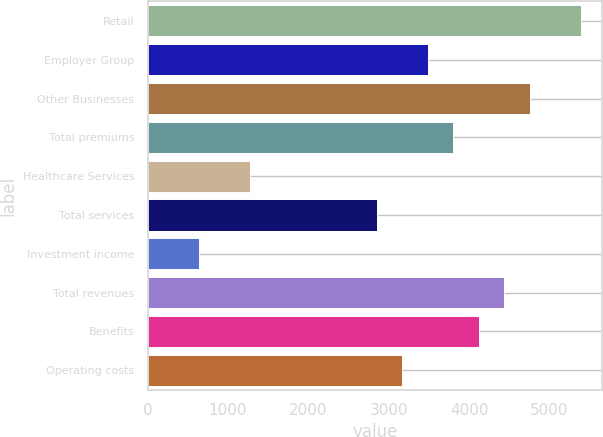Convert chart to OTSL. <chart><loc_0><loc_0><loc_500><loc_500><bar_chart><fcel>Retail<fcel>Employer Group<fcel>Other Businesses<fcel>Total premiums<fcel>Healthcare Services<fcel>Total services<fcel>Investment income<fcel>Total revenues<fcel>Benefits<fcel>Operating costs<nl><fcel>5388.29<fcel>3486.89<fcel>4754.49<fcel>3803.79<fcel>1268.59<fcel>2853.09<fcel>634.79<fcel>4437.59<fcel>4120.69<fcel>3169.99<nl></chart> 